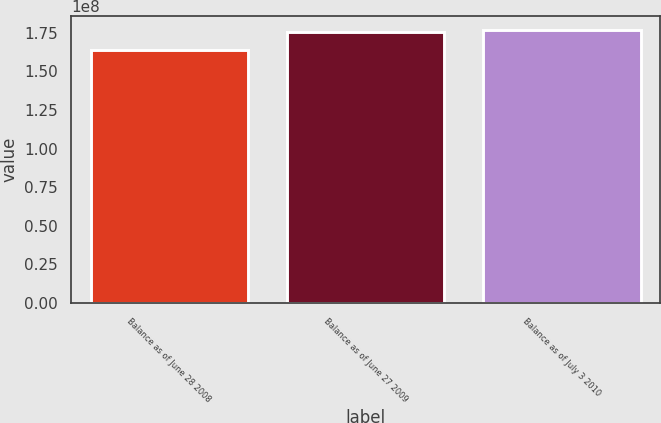<chart> <loc_0><loc_0><loc_500><loc_500><bar_chart><fcel>Balance as of June 28 2008<fcel>Balance as of June 27 2009<fcel>Balance as of July 3 2010<nl><fcel>1.63942e+08<fcel>1.75148e+08<fcel>1.76769e+08<nl></chart> 